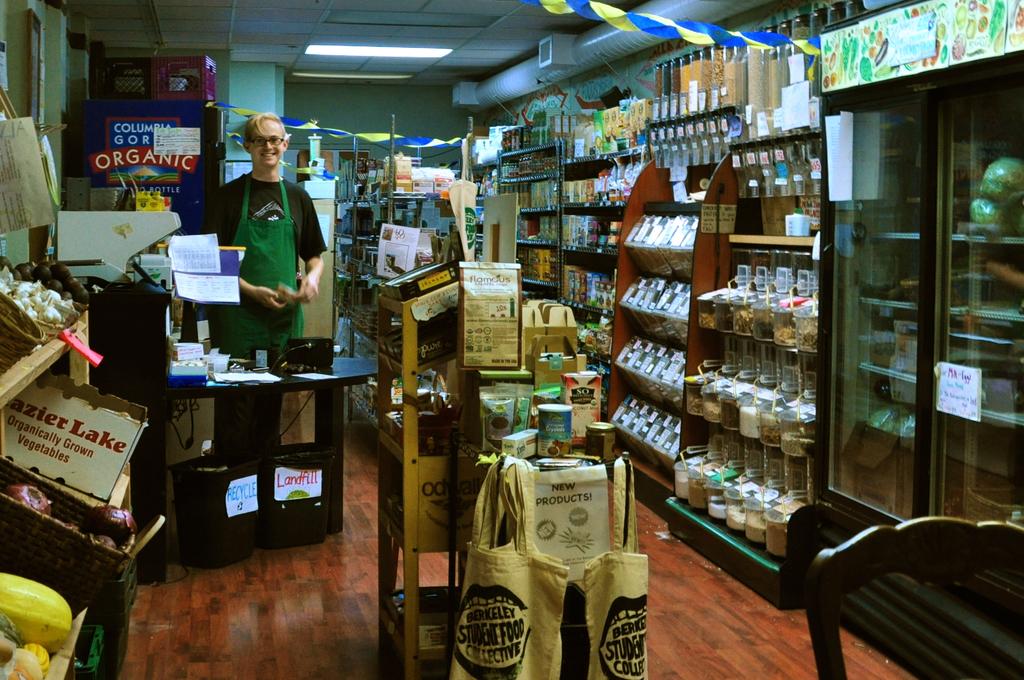What does that white box say? organically grown what?
Offer a very short reply. Vegetables. On the left does it say frazier lake or something else?
Give a very brief answer. Yes. 